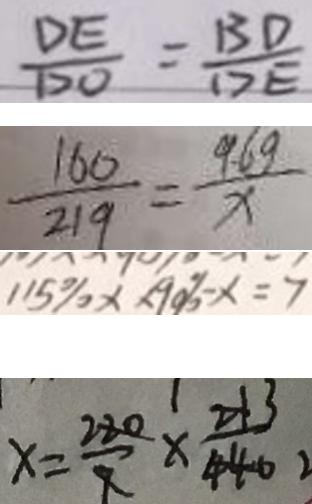Convert formula to latex. <formula><loc_0><loc_0><loc_500><loc_500>\frac { D E } { D O } = \frac { B D } { D E } 
 \frac { 1 6 0 } { 2 1 9 } = \frac { 9 . 6 g } { x } 
 1 1 5 \% x \times 9 0 \% - x = 7 
 x = \frac { 2 2 0 } { 9 } \times \frac { 3 } { 4 4 0 }</formula> 